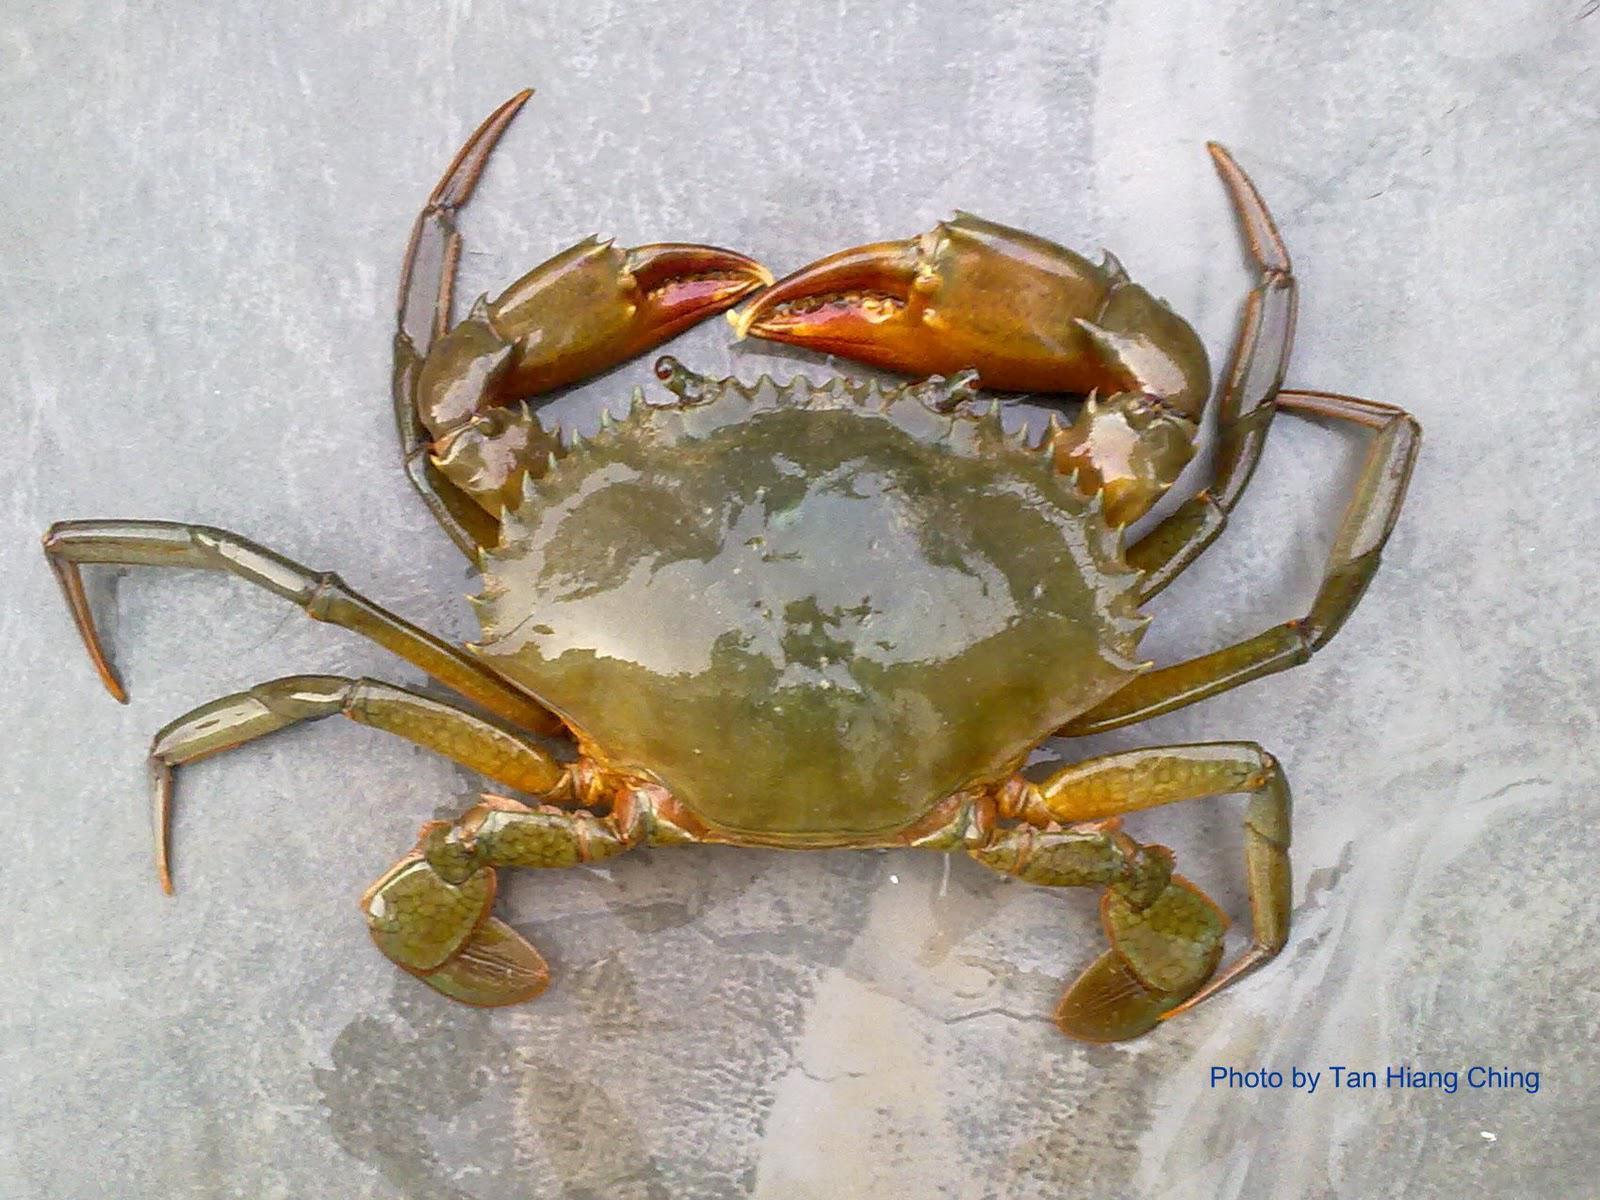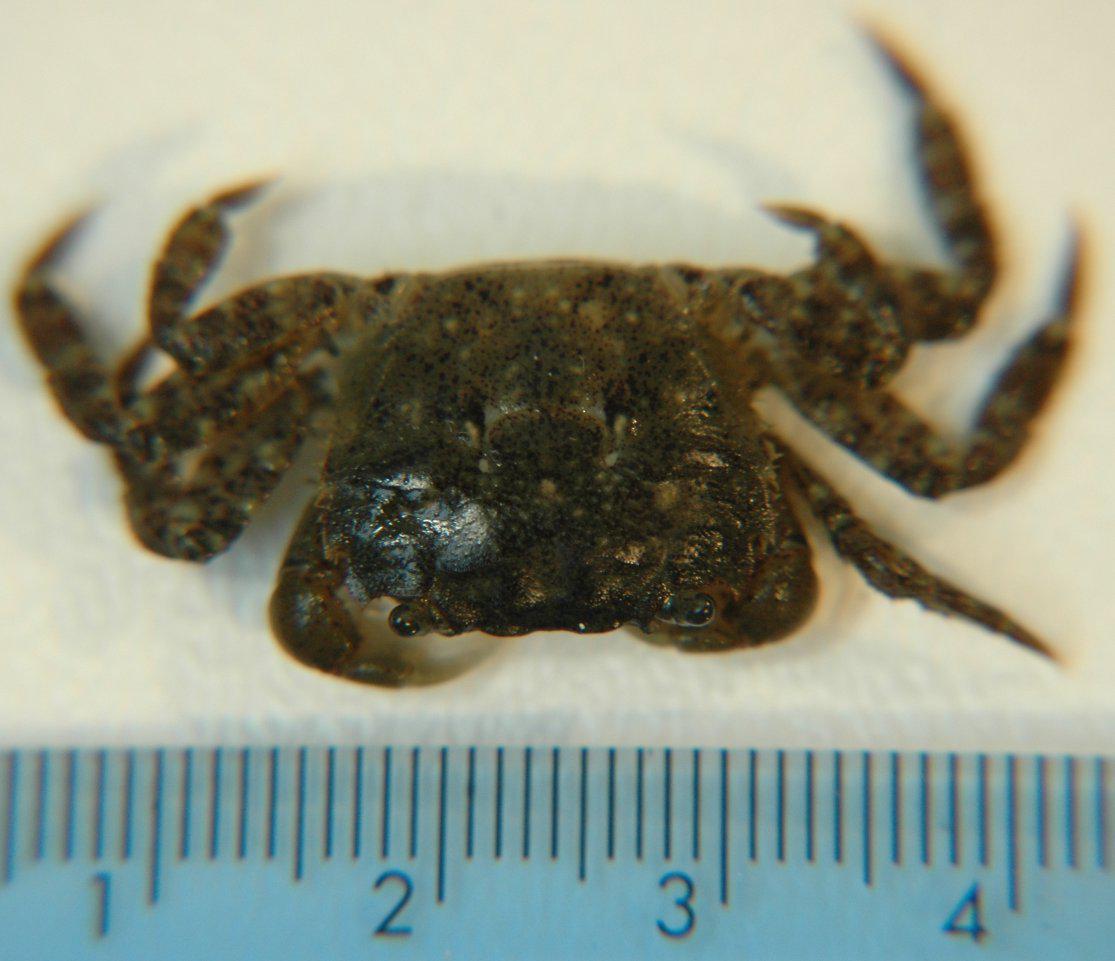The first image is the image on the left, the second image is the image on the right. Given the left and right images, does the statement "There are exactly two crabs." hold true? Answer yes or no. Yes. The first image is the image on the left, the second image is the image on the right. For the images shown, is this caption "An image shows a ruler displayed horizontally under a crab facing forward." true? Answer yes or no. Yes. 